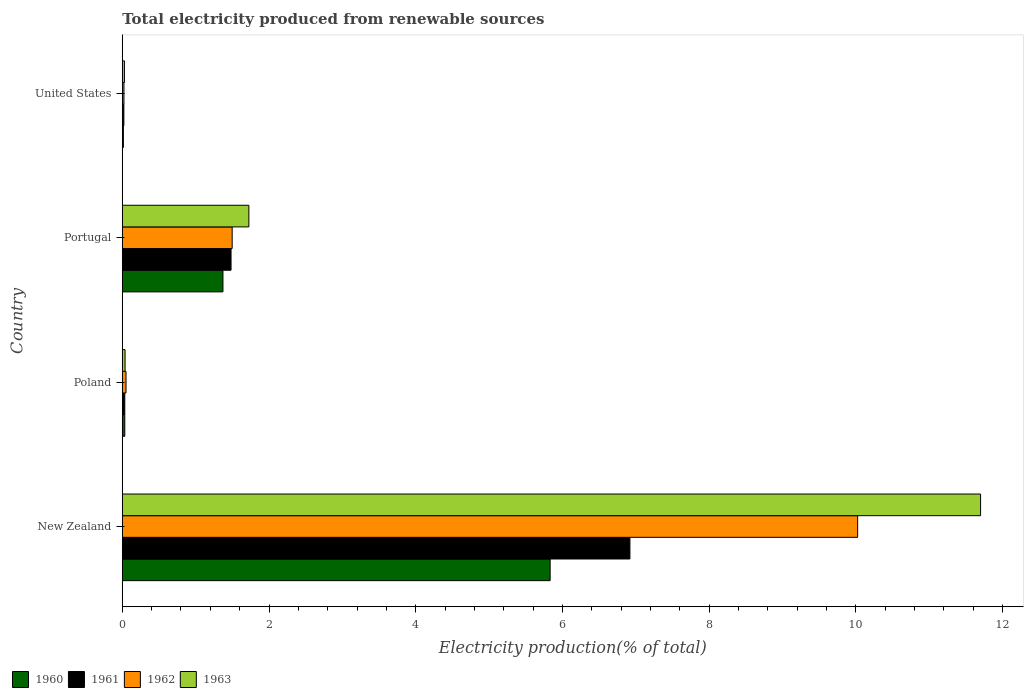Are the number of bars on each tick of the Y-axis equal?
Ensure brevity in your answer.  Yes. How many bars are there on the 3rd tick from the top?
Your response must be concise. 4. What is the label of the 4th group of bars from the top?
Your response must be concise. New Zealand. In how many cases, is the number of bars for a given country not equal to the number of legend labels?
Ensure brevity in your answer.  0. What is the total electricity produced in 1961 in New Zealand?
Make the answer very short. 6.92. Across all countries, what is the maximum total electricity produced in 1961?
Your answer should be very brief. 6.92. Across all countries, what is the minimum total electricity produced in 1961?
Your answer should be compact. 0.02. In which country was the total electricity produced in 1962 maximum?
Ensure brevity in your answer.  New Zealand. In which country was the total electricity produced in 1961 minimum?
Your answer should be very brief. United States. What is the total total electricity produced in 1961 in the graph?
Ensure brevity in your answer.  8.46. What is the difference between the total electricity produced in 1960 in Poland and that in United States?
Your answer should be compact. 0.02. What is the difference between the total electricity produced in 1960 in United States and the total electricity produced in 1962 in New Zealand?
Your answer should be very brief. -10.01. What is the average total electricity produced in 1962 per country?
Offer a terse response. 2.9. What is the difference between the total electricity produced in 1963 and total electricity produced in 1960 in Poland?
Your answer should be very brief. 0. What is the ratio of the total electricity produced in 1960 in New Zealand to that in Portugal?
Keep it short and to the point. 4.25. Is the difference between the total electricity produced in 1963 in New Zealand and Poland greater than the difference between the total electricity produced in 1960 in New Zealand and Poland?
Provide a succinct answer. Yes. What is the difference between the highest and the second highest total electricity produced in 1960?
Make the answer very short. 4.46. What is the difference between the highest and the lowest total electricity produced in 1960?
Provide a succinct answer. 5.82. What does the 1st bar from the top in Poland represents?
Keep it short and to the point. 1963. What does the 3rd bar from the bottom in Portugal represents?
Offer a very short reply. 1962. Are all the bars in the graph horizontal?
Your answer should be very brief. Yes. Where does the legend appear in the graph?
Your answer should be very brief. Bottom left. How many legend labels are there?
Offer a terse response. 4. What is the title of the graph?
Make the answer very short. Total electricity produced from renewable sources. What is the label or title of the Y-axis?
Your answer should be very brief. Country. What is the Electricity production(% of total) in 1960 in New Zealand?
Make the answer very short. 5.83. What is the Electricity production(% of total) of 1961 in New Zealand?
Provide a short and direct response. 6.92. What is the Electricity production(% of total) of 1962 in New Zealand?
Your answer should be compact. 10.02. What is the Electricity production(% of total) of 1963 in New Zealand?
Make the answer very short. 11.7. What is the Electricity production(% of total) in 1960 in Poland?
Your response must be concise. 0.03. What is the Electricity production(% of total) in 1961 in Poland?
Your answer should be very brief. 0.03. What is the Electricity production(% of total) of 1962 in Poland?
Offer a very short reply. 0.05. What is the Electricity production(% of total) in 1963 in Poland?
Ensure brevity in your answer.  0.04. What is the Electricity production(% of total) of 1960 in Portugal?
Keep it short and to the point. 1.37. What is the Electricity production(% of total) of 1961 in Portugal?
Make the answer very short. 1.48. What is the Electricity production(% of total) of 1962 in Portugal?
Your response must be concise. 1.5. What is the Electricity production(% of total) of 1963 in Portugal?
Your answer should be compact. 1.73. What is the Electricity production(% of total) of 1960 in United States?
Your answer should be very brief. 0.02. What is the Electricity production(% of total) in 1961 in United States?
Offer a very short reply. 0.02. What is the Electricity production(% of total) in 1962 in United States?
Provide a succinct answer. 0.02. What is the Electricity production(% of total) of 1963 in United States?
Make the answer very short. 0.03. Across all countries, what is the maximum Electricity production(% of total) in 1960?
Make the answer very short. 5.83. Across all countries, what is the maximum Electricity production(% of total) of 1961?
Make the answer very short. 6.92. Across all countries, what is the maximum Electricity production(% of total) in 1962?
Offer a very short reply. 10.02. Across all countries, what is the maximum Electricity production(% of total) of 1963?
Offer a terse response. 11.7. Across all countries, what is the minimum Electricity production(% of total) of 1960?
Provide a short and direct response. 0.02. Across all countries, what is the minimum Electricity production(% of total) in 1961?
Provide a succinct answer. 0.02. Across all countries, what is the minimum Electricity production(% of total) of 1962?
Ensure brevity in your answer.  0.02. Across all countries, what is the minimum Electricity production(% of total) of 1963?
Offer a terse response. 0.03. What is the total Electricity production(% of total) of 1960 in the graph?
Offer a very short reply. 7.25. What is the total Electricity production(% of total) of 1961 in the graph?
Give a very brief answer. 8.46. What is the total Electricity production(% of total) of 1962 in the graph?
Ensure brevity in your answer.  11.6. What is the total Electricity production(% of total) in 1963 in the graph?
Your response must be concise. 13.49. What is the difference between the Electricity production(% of total) of 1960 in New Zealand and that in Poland?
Provide a short and direct response. 5.8. What is the difference between the Electricity production(% of total) in 1961 in New Zealand and that in Poland?
Your answer should be compact. 6.89. What is the difference between the Electricity production(% of total) of 1962 in New Zealand and that in Poland?
Ensure brevity in your answer.  9.97. What is the difference between the Electricity production(% of total) in 1963 in New Zealand and that in Poland?
Ensure brevity in your answer.  11.66. What is the difference between the Electricity production(% of total) of 1960 in New Zealand and that in Portugal?
Make the answer very short. 4.46. What is the difference between the Electricity production(% of total) in 1961 in New Zealand and that in Portugal?
Your answer should be very brief. 5.44. What is the difference between the Electricity production(% of total) in 1962 in New Zealand and that in Portugal?
Keep it short and to the point. 8.53. What is the difference between the Electricity production(% of total) of 1963 in New Zealand and that in Portugal?
Give a very brief answer. 9.97. What is the difference between the Electricity production(% of total) of 1960 in New Zealand and that in United States?
Provide a short and direct response. 5.82. What is the difference between the Electricity production(% of total) in 1961 in New Zealand and that in United States?
Keep it short and to the point. 6.9. What is the difference between the Electricity production(% of total) of 1962 in New Zealand and that in United States?
Provide a short and direct response. 10. What is the difference between the Electricity production(% of total) in 1963 in New Zealand and that in United States?
Your answer should be very brief. 11.67. What is the difference between the Electricity production(% of total) of 1960 in Poland and that in Portugal?
Keep it short and to the point. -1.34. What is the difference between the Electricity production(% of total) in 1961 in Poland and that in Portugal?
Provide a succinct answer. -1.45. What is the difference between the Electricity production(% of total) of 1962 in Poland and that in Portugal?
Your response must be concise. -1.45. What is the difference between the Electricity production(% of total) of 1963 in Poland and that in Portugal?
Make the answer very short. -1.69. What is the difference between the Electricity production(% of total) of 1960 in Poland and that in United States?
Offer a terse response. 0.02. What is the difference between the Electricity production(% of total) in 1961 in Poland and that in United States?
Provide a succinct answer. 0.01. What is the difference between the Electricity production(% of total) of 1962 in Poland and that in United States?
Offer a terse response. 0.03. What is the difference between the Electricity production(% of total) of 1963 in Poland and that in United States?
Your response must be concise. 0.01. What is the difference between the Electricity production(% of total) in 1960 in Portugal and that in United States?
Give a very brief answer. 1.36. What is the difference between the Electricity production(% of total) of 1961 in Portugal and that in United States?
Offer a terse response. 1.46. What is the difference between the Electricity production(% of total) of 1962 in Portugal and that in United States?
Give a very brief answer. 1.48. What is the difference between the Electricity production(% of total) in 1963 in Portugal and that in United States?
Your answer should be very brief. 1.7. What is the difference between the Electricity production(% of total) of 1960 in New Zealand and the Electricity production(% of total) of 1961 in Poland?
Make the answer very short. 5.8. What is the difference between the Electricity production(% of total) of 1960 in New Zealand and the Electricity production(% of total) of 1962 in Poland?
Your response must be concise. 5.78. What is the difference between the Electricity production(% of total) of 1960 in New Zealand and the Electricity production(% of total) of 1963 in Poland?
Make the answer very short. 5.79. What is the difference between the Electricity production(% of total) in 1961 in New Zealand and the Electricity production(% of total) in 1962 in Poland?
Offer a very short reply. 6.87. What is the difference between the Electricity production(% of total) of 1961 in New Zealand and the Electricity production(% of total) of 1963 in Poland?
Provide a short and direct response. 6.88. What is the difference between the Electricity production(% of total) of 1962 in New Zealand and the Electricity production(% of total) of 1963 in Poland?
Provide a succinct answer. 9.99. What is the difference between the Electricity production(% of total) in 1960 in New Zealand and the Electricity production(% of total) in 1961 in Portugal?
Your answer should be very brief. 4.35. What is the difference between the Electricity production(% of total) of 1960 in New Zealand and the Electricity production(% of total) of 1962 in Portugal?
Offer a very short reply. 4.33. What is the difference between the Electricity production(% of total) of 1960 in New Zealand and the Electricity production(% of total) of 1963 in Portugal?
Make the answer very short. 4.11. What is the difference between the Electricity production(% of total) in 1961 in New Zealand and the Electricity production(% of total) in 1962 in Portugal?
Offer a very short reply. 5.42. What is the difference between the Electricity production(% of total) of 1961 in New Zealand and the Electricity production(% of total) of 1963 in Portugal?
Provide a succinct answer. 5.19. What is the difference between the Electricity production(% of total) of 1962 in New Zealand and the Electricity production(% of total) of 1963 in Portugal?
Provide a short and direct response. 8.3. What is the difference between the Electricity production(% of total) in 1960 in New Zealand and the Electricity production(% of total) in 1961 in United States?
Give a very brief answer. 5.81. What is the difference between the Electricity production(% of total) of 1960 in New Zealand and the Electricity production(% of total) of 1962 in United States?
Keep it short and to the point. 5.81. What is the difference between the Electricity production(% of total) in 1960 in New Zealand and the Electricity production(% of total) in 1963 in United States?
Give a very brief answer. 5.8. What is the difference between the Electricity production(% of total) of 1961 in New Zealand and the Electricity production(% of total) of 1962 in United States?
Provide a short and direct response. 6.9. What is the difference between the Electricity production(% of total) in 1961 in New Zealand and the Electricity production(% of total) in 1963 in United States?
Your answer should be very brief. 6.89. What is the difference between the Electricity production(% of total) of 1962 in New Zealand and the Electricity production(% of total) of 1963 in United States?
Keep it short and to the point. 10. What is the difference between the Electricity production(% of total) in 1960 in Poland and the Electricity production(% of total) in 1961 in Portugal?
Offer a terse response. -1.45. What is the difference between the Electricity production(% of total) of 1960 in Poland and the Electricity production(% of total) of 1962 in Portugal?
Give a very brief answer. -1.46. What is the difference between the Electricity production(% of total) of 1960 in Poland and the Electricity production(% of total) of 1963 in Portugal?
Your response must be concise. -1.69. What is the difference between the Electricity production(% of total) of 1961 in Poland and the Electricity production(% of total) of 1962 in Portugal?
Provide a succinct answer. -1.46. What is the difference between the Electricity production(% of total) in 1961 in Poland and the Electricity production(% of total) in 1963 in Portugal?
Your answer should be compact. -1.69. What is the difference between the Electricity production(% of total) of 1962 in Poland and the Electricity production(% of total) of 1963 in Portugal?
Provide a succinct answer. -1.67. What is the difference between the Electricity production(% of total) of 1960 in Poland and the Electricity production(% of total) of 1961 in United States?
Your response must be concise. 0.01. What is the difference between the Electricity production(% of total) of 1960 in Poland and the Electricity production(% of total) of 1962 in United States?
Offer a very short reply. 0.01. What is the difference between the Electricity production(% of total) of 1960 in Poland and the Electricity production(% of total) of 1963 in United States?
Keep it short and to the point. 0. What is the difference between the Electricity production(% of total) in 1961 in Poland and the Electricity production(% of total) in 1962 in United States?
Your response must be concise. 0.01. What is the difference between the Electricity production(% of total) in 1961 in Poland and the Electricity production(% of total) in 1963 in United States?
Keep it short and to the point. 0. What is the difference between the Electricity production(% of total) of 1962 in Poland and the Electricity production(% of total) of 1963 in United States?
Give a very brief answer. 0.02. What is the difference between the Electricity production(% of total) of 1960 in Portugal and the Electricity production(% of total) of 1961 in United States?
Offer a terse response. 1.35. What is the difference between the Electricity production(% of total) of 1960 in Portugal and the Electricity production(% of total) of 1962 in United States?
Give a very brief answer. 1.35. What is the difference between the Electricity production(% of total) in 1960 in Portugal and the Electricity production(% of total) in 1963 in United States?
Provide a succinct answer. 1.34. What is the difference between the Electricity production(% of total) of 1961 in Portugal and the Electricity production(% of total) of 1962 in United States?
Ensure brevity in your answer.  1.46. What is the difference between the Electricity production(% of total) of 1961 in Portugal and the Electricity production(% of total) of 1963 in United States?
Ensure brevity in your answer.  1.45. What is the difference between the Electricity production(% of total) of 1962 in Portugal and the Electricity production(% of total) of 1963 in United States?
Provide a short and direct response. 1.47. What is the average Electricity production(% of total) of 1960 per country?
Your answer should be very brief. 1.81. What is the average Electricity production(% of total) in 1961 per country?
Make the answer very short. 2.11. What is the average Electricity production(% of total) in 1962 per country?
Give a very brief answer. 2.9. What is the average Electricity production(% of total) in 1963 per country?
Your response must be concise. 3.37. What is the difference between the Electricity production(% of total) of 1960 and Electricity production(% of total) of 1961 in New Zealand?
Provide a short and direct response. -1.09. What is the difference between the Electricity production(% of total) in 1960 and Electricity production(% of total) in 1962 in New Zealand?
Provide a short and direct response. -4.19. What is the difference between the Electricity production(% of total) of 1960 and Electricity production(% of total) of 1963 in New Zealand?
Keep it short and to the point. -5.87. What is the difference between the Electricity production(% of total) of 1961 and Electricity production(% of total) of 1962 in New Zealand?
Ensure brevity in your answer.  -3.1. What is the difference between the Electricity production(% of total) in 1961 and Electricity production(% of total) in 1963 in New Zealand?
Give a very brief answer. -4.78. What is the difference between the Electricity production(% of total) in 1962 and Electricity production(% of total) in 1963 in New Zealand?
Make the answer very short. -1.68. What is the difference between the Electricity production(% of total) of 1960 and Electricity production(% of total) of 1962 in Poland?
Provide a short and direct response. -0.02. What is the difference between the Electricity production(% of total) in 1960 and Electricity production(% of total) in 1963 in Poland?
Ensure brevity in your answer.  -0. What is the difference between the Electricity production(% of total) in 1961 and Electricity production(% of total) in 1962 in Poland?
Your response must be concise. -0.02. What is the difference between the Electricity production(% of total) of 1961 and Electricity production(% of total) of 1963 in Poland?
Your response must be concise. -0. What is the difference between the Electricity production(% of total) in 1962 and Electricity production(% of total) in 1963 in Poland?
Give a very brief answer. 0.01. What is the difference between the Electricity production(% of total) in 1960 and Electricity production(% of total) in 1961 in Portugal?
Offer a terse response. -0.11. What is the difference between the Electricity production(% of total) in 1960 and Electricity production(% of total) in 1962 in Portugal?
Keep it short and to the point. -0.13. What is the difference between the Electricity production(% of total) in 1960 and Electricity production(% of total) in 1963 in Portugal?
Your answer should be compact. -0.35. What is the difference between the Electricity production(% of total) in 1961 and Electricity production(% of total) in 1962 in Portugal?
Offer a very short reply. -0.02. What is the difference between the Electricity production(% of total) of 1961 and Electricity production(% of total) of 1963 in Portugal?
Keep it short and to the point. -0.24. What is the difference between the Electricity production(% of total) of 1962 and Electricity production(% of total) of 1963 in Portugal?
Your answer should be very brief. -0.23. What is the difference between the Electricity production(% of total) in 1960 and Electricity production(% of total) in 1961 in United States?
Offer a terse response. -0.01. What is the difference between the Electricity production(% of total) in 1960 and Electricity production(% of total) in 1962 in United States?
Offer a terse response. -0.01. What is the difference between the Electricity production(% of total) in 1960 and Electricity production(% of total) in 1963 in United States?
Your answer should be very brief. -0.01. What is the difference between the Electricity production(% of total) of 1961 and Electricity production(% of total) of 1962 in United States?
Provide a short and direct response. -0. What is the difference between the Electricity production(% of total) of 1961 and Electricity production(% of total) of 1963 in United States?
Ensure brevity in your answer.  -0.01. What is the difference between the Electricity production(% of total) in 1962 and Electricity production(% of total) in 1963 in United States?
Offer a very short reply. -0.01. What is the ratio of the Electricity production(% of total) of 1960 in New Zealand to that in Poland?
Provide a short and direct response. 170.79. What is the ratio of the Electricity production(% of total) in 1961 in New Zealand to that in Poland?
Keep it short and to the point. 202.83. What is the ratio of the Electricity production(% of total) of 1962 in New Zealand to that in Poland?
Offer a terse response. 196.95. What is the ratio of the Electricity production(% of total) of 1963 in New Zealand to that in Poland?
Offer a terse response. 308.73. What is the ratio of the Electricity production(% of total) in 1960 in New Zealand to that in Portugal?
Your answer should be compact. 4.25. What is the ratio of the Electricity production(% of total) in 1961 in New Zealand to that in Portugal?
Your response must be concise. 4.67. What is the ratio of the Electricity production(% of total) in 1962 in New Zealand to that in Portugal?
Your answer should be compact. 6.69. What is the ratio of the Electricity production(% of total) of 1963 in New Zealand to that in Portugal?
Ensure brevity in your answer.  6.78. What is the ratio of the Electricity production(% of total) in 1960 in New Zealand to that in United States?
Offer a terse response. 382.31. What is the ratio of the Electricity production(% of total) of 1961 in New Zealand to that in United States?
Your answer should be compact. 321.25. What is the ratio of the Electricity production(% of total) of 1962 in New Zealand to that in United States?
Offer a terse response. 439.93. What is the ratio of the Electricity production(% of total) in 1963 in New Zealand to that in United States?
Provide a short and direct response. 397.5. What is the ratio of the Electricity production(% of total) in 1960 in Poland to that in Portugal?
Provide a short and direct response. 0.02. What is the ratio of the Electricity production(% of total) in 1961 in Poland to that in Portugal?
Offer a terse response. 0.02. What is the ratio of the Electricity production(% of total) in 1962 in Poland to that in Portugal?
Provide a succinct answer. 0.03. What is the ratio of the Electricity production(% of total) of 1963 in Poland to that in Portugal?
Offer a terse response. 0.02. What is the ratio of the Electricity production(% of total) in 1960 in Poland to that in United States?
Your response must be concise. 2.24. What is the ratio of the Electricity production(% of total) in 1961 in Poland to that in United States?
Your answer should be compact. 1.58. What is the ratio of the Electricity production(% of total) in 1962 in Poland to that in United States?
Your answer should be very brief. 2.23. What is the ratio of the Electricity production(% of total) of 1963 in Poland to that in United States?
Offer a very short reply. 1.29. What is the ratio of the Electricity production(% of total) of 1960 in Portugal to that in United States?
Keep it short and to the point. 89.96. What is the ratio of the Electricity production(% of total) in 1961 in Portugal to that in United States?
Your answer should be very brief. 68.83. What is the ratio of the Electricity production(% of total) in 1962 in Portugal to that in United States?
Offer a terse response. 65.74. What is the ratio of the Electricity production(% of total) of 1963 in Portugal to that in United States?
Your answer should be very brief. 58.63. What is the difference between the highest and the second highest Electricity production(% of total) in 1960?
Your answer should be compact. 4.46. What is the difference between the highest and the second highest Electricity production(% of total) of 1961?
Your answer should be very brief. 5.44. What is the difference between the highest and the second highest Electricity production(% of total) in 1962?
Provide a succinct answer. 8.53. What is the difference between the highest and the second highest Electricity production(% of total) of 1963?
Offer a very short reply. 9.97. What is the difference between the highest and the lowest Electricity production(% of total) in 1960?
Provide a succinct answer. 5.82. What is the difference between the highest and the lowest Electricity production(% of total) in 1961?
Offer a very short reply. 6.9. What is the difference between the highest and the lowest Electricity production(% of total) in 1962?
Make the answer very short. 10. What is the difference between the highest and the lowest Electricity production(% of total) of 1963?
Give a very brief answer. 11.67. 